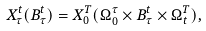<formula> <loc_0><loc_0><loc_500><loc_500>X _ { \tau } ^ { t } ( B _ { \tau } ^ { t } ) = X _ { 0 } ^ { T } ( \Omega _ { 0 } ^ { \tau } \times B _ { \tau } ^ { t } \times \Omega _ { t } ^ { T } ) ,</formula> 